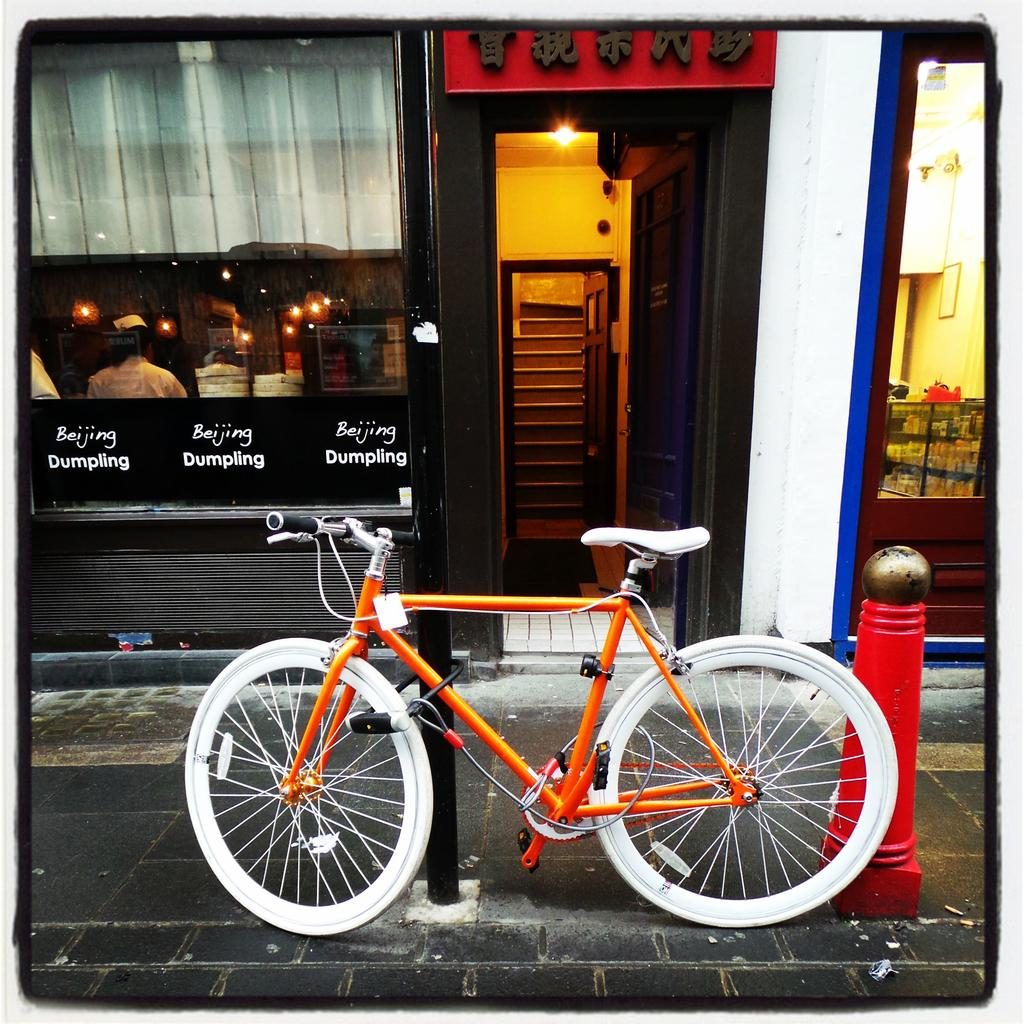What is the main object in the image? There is a bicycle in the image. What can be seen on the ground in the image? There are poles on the ground in the image. What is visible in the background of the image? There is a shelter visible in the background of the image, and there are objects present in the background as well. How many jellyfish can be seen swimming near the bicycle in the image? There are no jellyfish present in the image; it features a bicycle and poles on the ground. What type of worm is crawling on the poles in the image? There are no worms present on the poles in the image. 